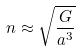<formula> <loc_0><loc_0><loc_500><loc_500>n \approx \sqrt { \frac { G } { a ^ { 3 } } }</formula> 